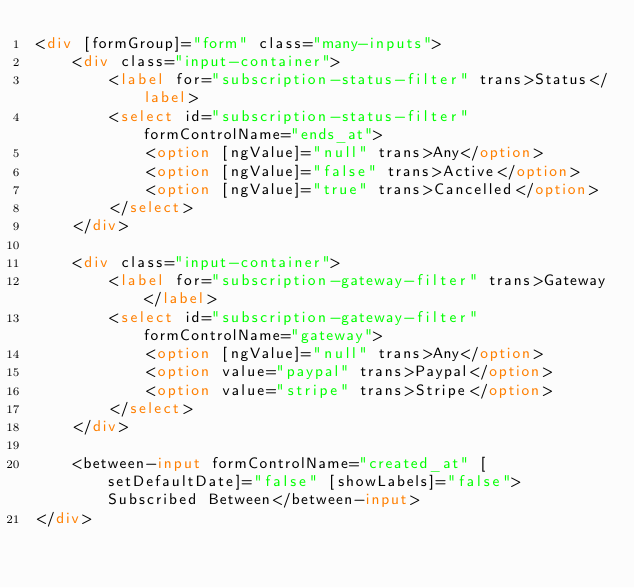Convert code to text. <code><loc_0><loc_0><loc_500><loc_500><_HTML_><div [formGroup]="form" class="many-inputs">
    <div class="input-container">
        <label for="subscription-status-filter" trans>Status</label>
        <select id="subscription-status-filter" formControlName="ends_at">
            <option [ngValue]="null" trans>Any</option>
            <option [ngValue]="false" trans>Active</option>
            <option [ngValue]="true" trans>Cancelled</option>
        </select>
    </div>

    <div class="input-container">
        <label for="subscription-gateway-filter" trans>Gateway</label>
        <select id="subscription-gateway-filter" formControlName="gateway">
            <option [ngValue]="null" trans>Any</option>
            <option value="paypal" trans>Paypal</option>
            <option value="stripe" trans>Stripe</option>
        </select>
    </div>

    <between-input formControlName="created_at" [setDefaultDate]="false" [showLabels]="false">Subscribed Between</between-input>
</div>
</code> 